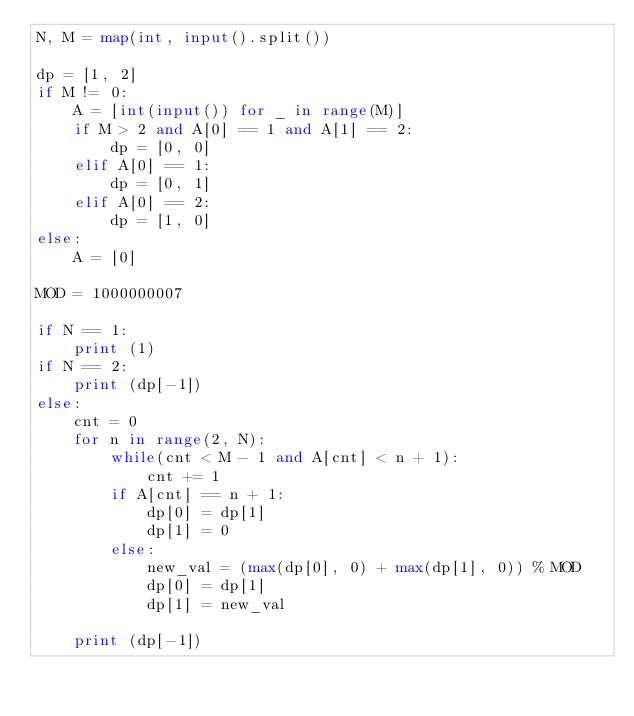<code> <loc_0><loc_0><loc_500><loc_500><_Python_>N, M = map(int, input().split())

dp = [1, 2]
if M != 0:
    A = [int(input()) for _ in range(M)]
    if M > 2 and A[0] == 1 and A[1] == 2:
        dp = [0, 0]
    elif A[0] == 1:
        dp = [0, 1]
    elif A[0] == 2:
        dp = [1, 0]
else:
    A = [0]

MOD = 1000000007

if N == 1:
    print (1)
if N == 2:
    print (dp[-1])
else:
    cnt = 0
    for n in range(2, N):
        while(cnt < M - 1 and A[cnt] < n + 1):
            cnt += 1
        if A[cnt] == n + 1:
            dp[0] = dp[1]
            dp[1] = 0
        else:
            new_val = (max(dp[0], 0) + max(dp[1], 0)) % MOD
            dp[0] = dp[1]
            dp[1] = new_val

    print (dp[-1])
</code> 